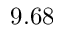<formula> <loc_0><loc_0><loc_500><loc_500>9 . 6 8</formula> 